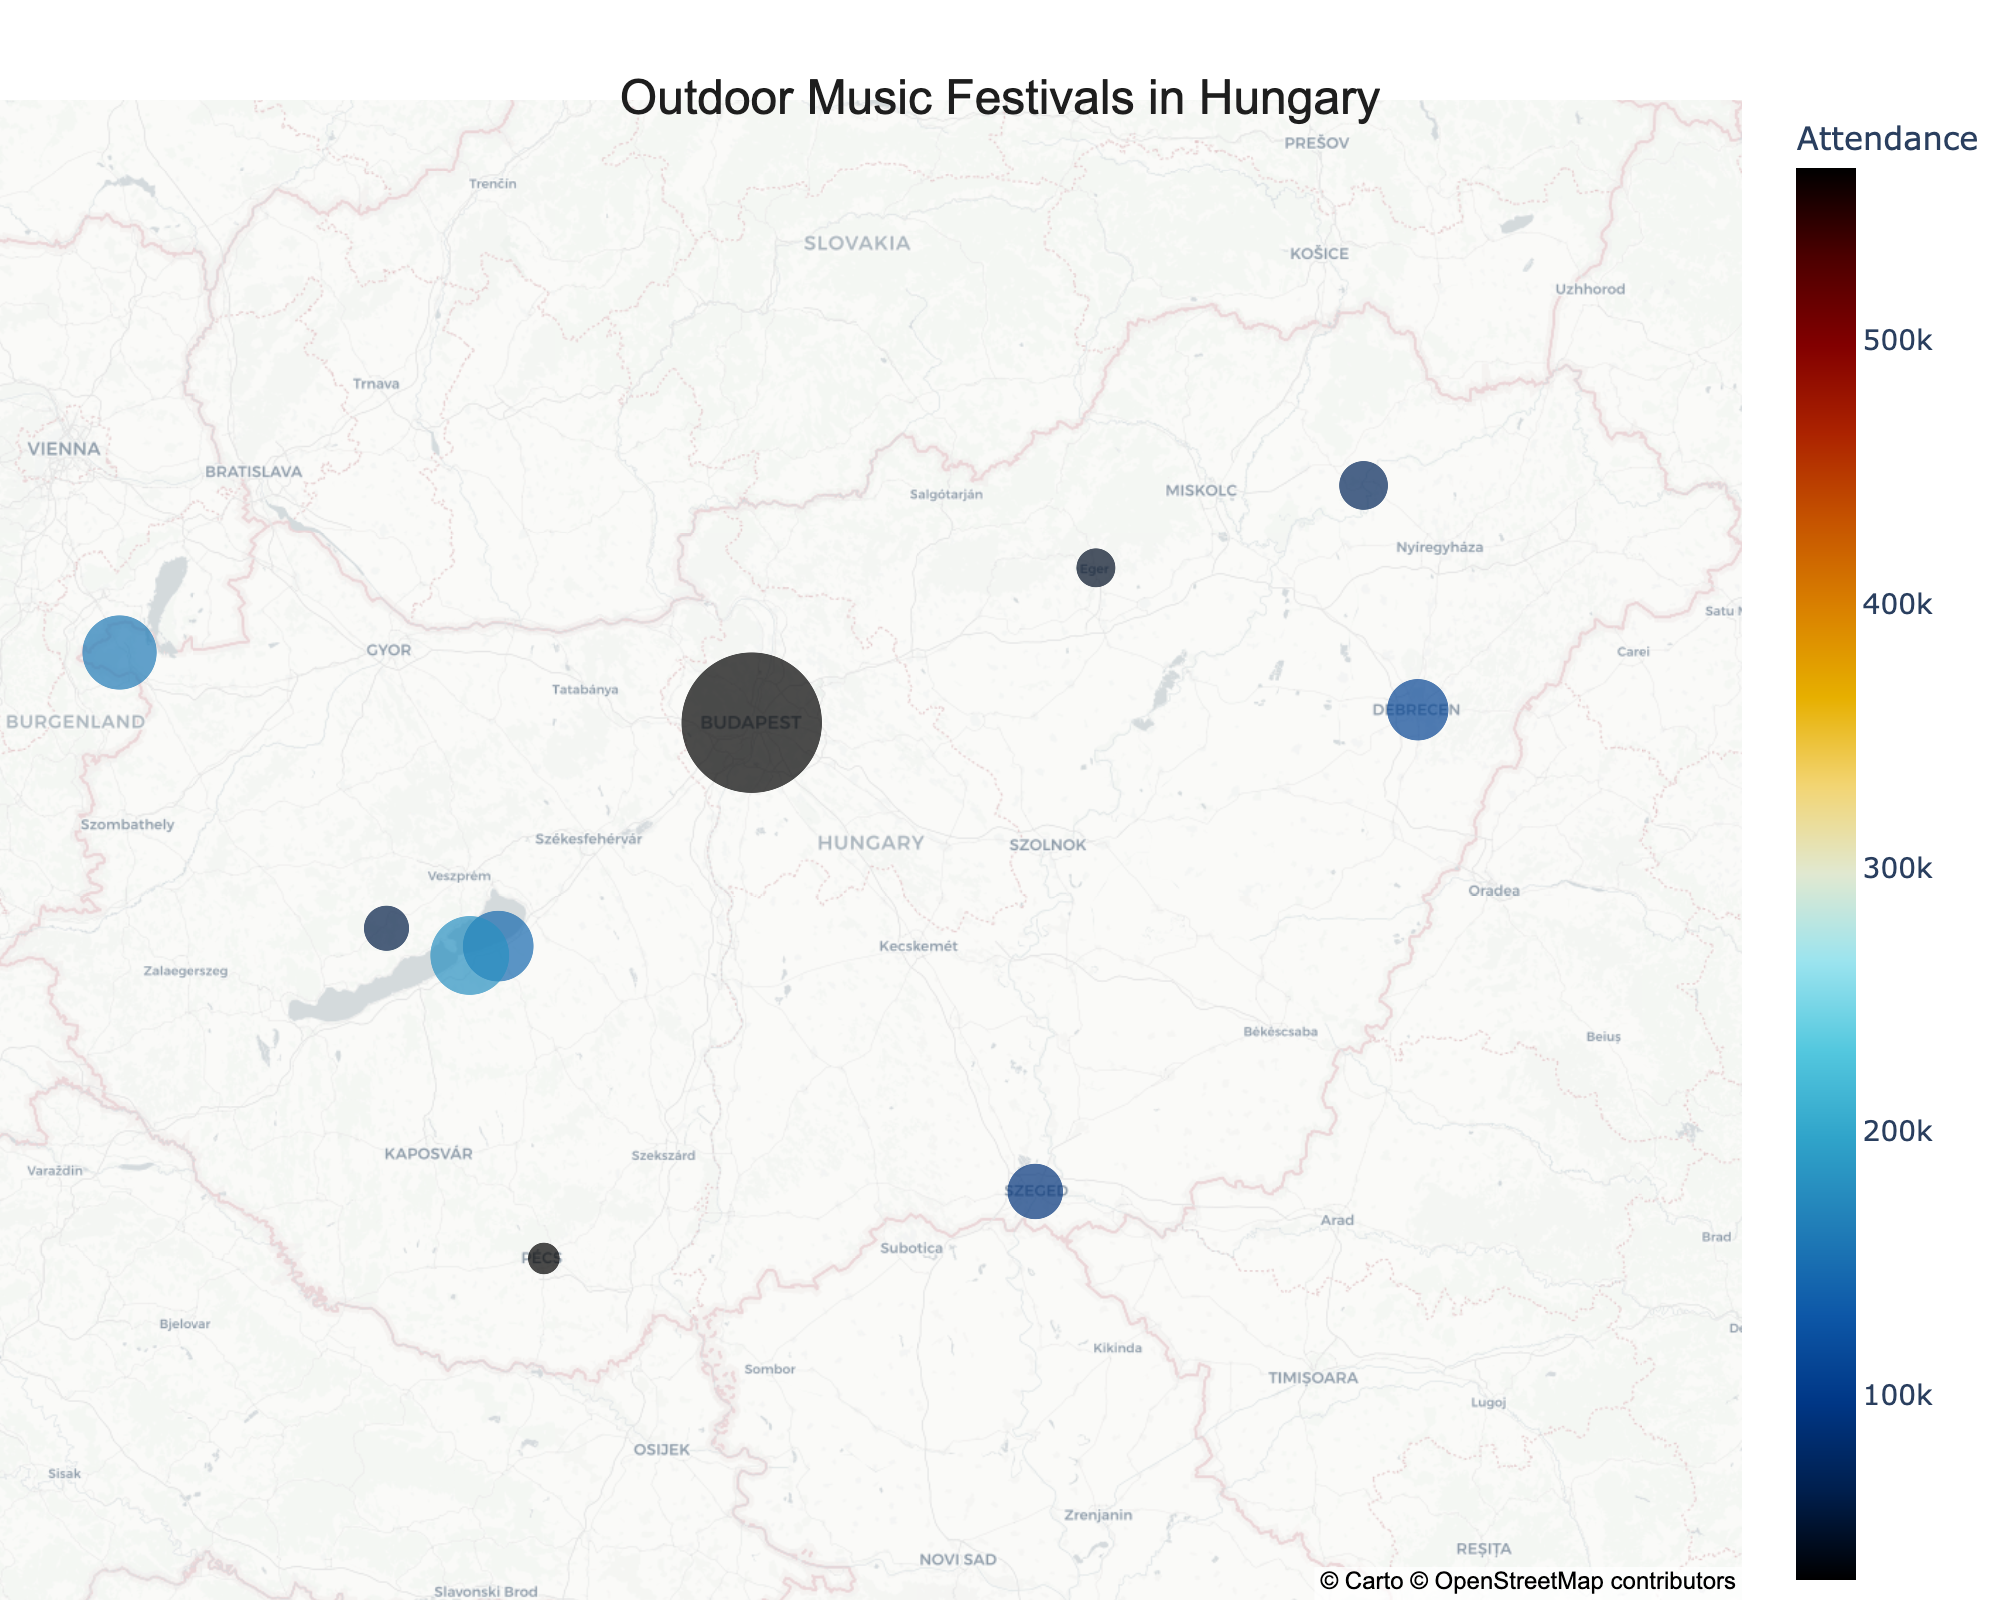Which festival has the highest attendance? Look at the size and color of the dots on the map and find the one with the highest value listed in the hover information.
Answer: Sziget Festival Which location is the southernmost on the map? Identify the dot located furthest south on the map by examining the positions relative to each other.
Answer: Pécs What's the total attendance for all festivals combined? Sum up the attendance figures for each festival: 145000 + 565000 + 160000 + 180000 + 110000 + 45000 + 90000 + 30000 + 60000 + 70000.
Answer: 1450000 Which festival has the lowest attendance? Look at the size and color of the dots on the map and find the one with the lowest value listed in the hover information.
Answer: Fishing on Orfű Compare the attendance of Sziget Festival and Balaton Sound. How much greater is the attendance of Sziget Festival? Subtract the attendance figure of Balaton Sound from that of Sziget Festival: 565000 - 145000.
Answer: 420000 Which festival is closest to Budapest? Identify the location of Budapest on the map and see which nearby dot corresponds to the nearest festival.
Answer: VOLT Festival in Sopron Calculate the average attendance for festivals located on Lake Balaton (Siófok and Zamárdi). Add the attendance of Balaton Sound (145000) and Strand Festival (180000) and divide by the number of festivals (2): (145000 + 180000) / 2.
Answer: 162500 What's the most northeastern festival? Identify the dot located furthest to the northeast on the map by examining the positions.
Answer: Hegyalja Festival in Tokaj 